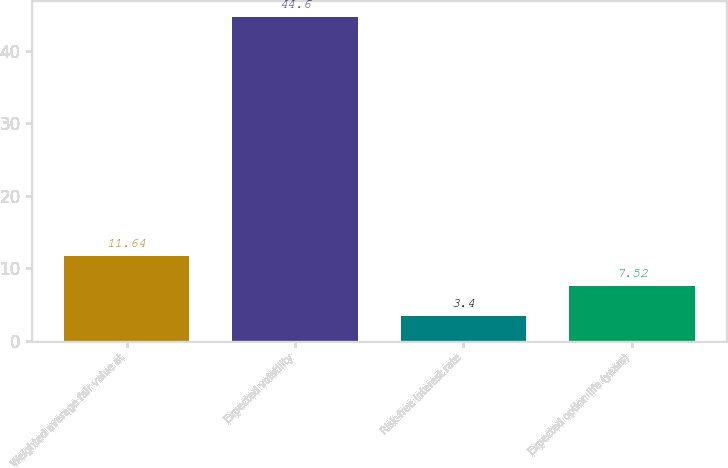<chart> <loc_0><loc_0><loc_500><loc_500><bar_chart><fcel>Weighted average fair value at<fcel>Expected volatility<fcel>Risk-free interest rate<fcel>Expected option life (years)<nl><fcel>11.64<fcel>44.6<fcel>3.4<fcel>7.52<nl></chart> 